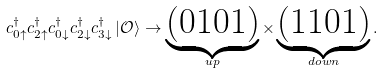Convert formula to latex. <formula><loc_0><loc_0><loc_500><loc_500>c _ { 0 \uparrow } ^ { \dagger } c _ { 2 \uparrow } ^ { \dagger } c _ { 0 \downarrow } ^ { \dagger } c _ { 2 \downarrow } ^ { \dagger } c _ { 3 \downarrow } ^ { \dagger } \left | \mathcal { O } \right \rangle \rightarrow \underbrace { ( 0 1 0 1 ) } _ { u p } \times \underbrace { ( 1 1 0 1 ) } _ { d o w n } .</formula> 